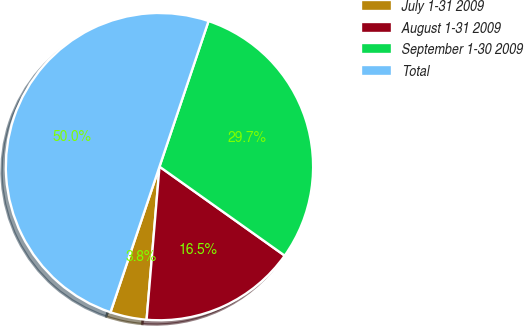<chart> <loc_0><loc_0><loc_500><loc_500><pie_chart><fcel>July 1-31 2009<fcel>August 1-31 2009<fcel>September 1-30 2009<fcel>Total<nl><fcel>3.83%<fcel>16.5%<fcel>29.66%<fcel>50.0%<nl></chart> 